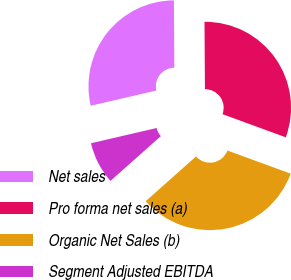Convert chart. <chart><loc_0><loc_0><loc_500><loc_500><pie_chart><fcel>Net sales<fcel>Pro forma net sales (a)<fcel>Organic Net Sales (b)<fcel>Segment Adjusted EBITDA<nl><fcel>28.53%<fcel>30.69%<fcel>32.85%<fcel>7.93%<nl></chart> 